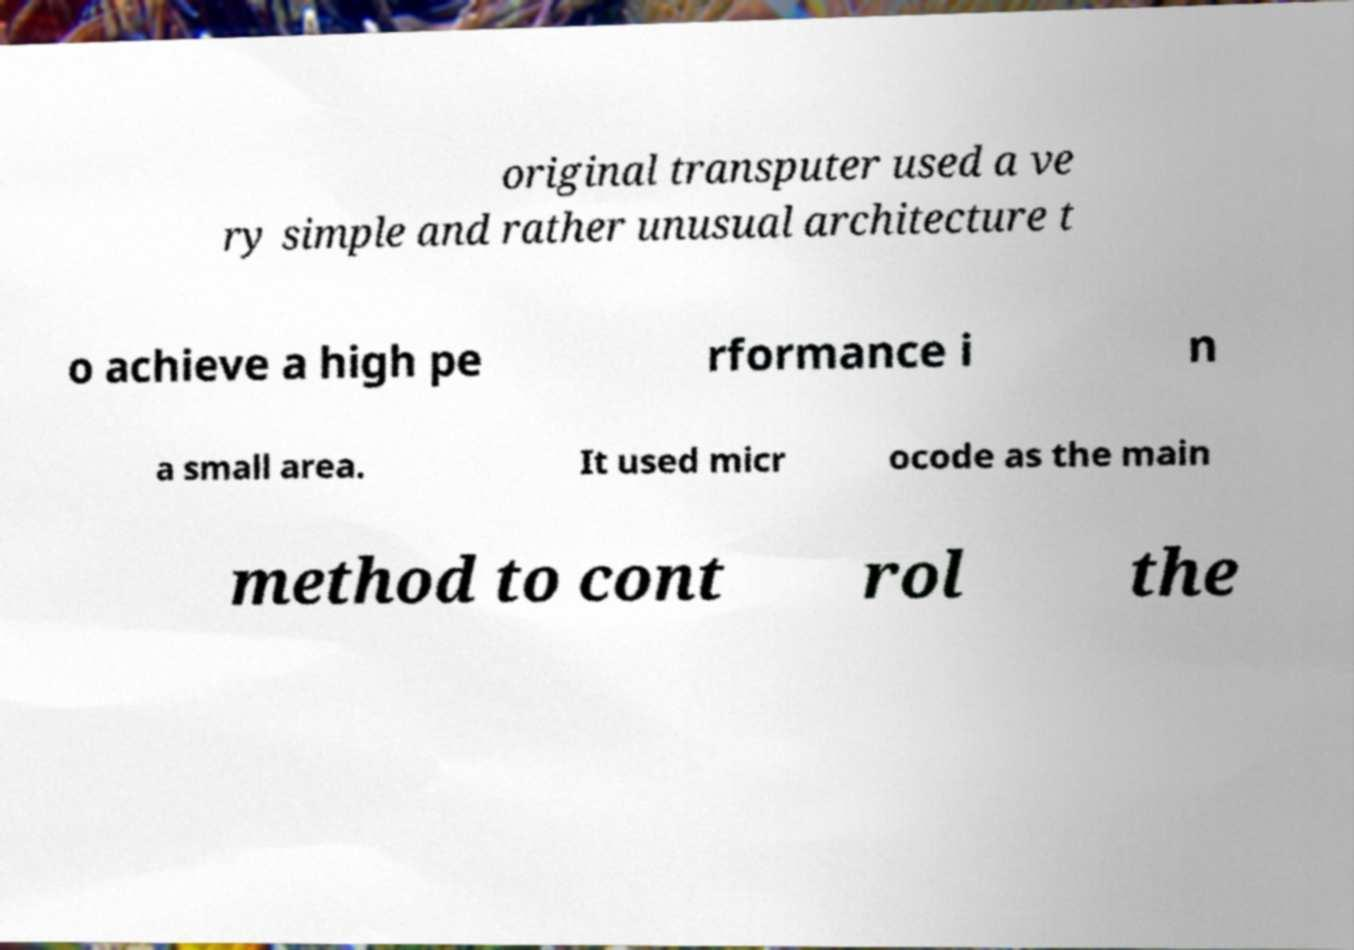Can you read and provide the text displayed in the image?This photo seems to have some interesting text. Can you extract and type it out for me? original transputer used a ve ry simple and rather unusual architecture t o achieve a high pe rformance i n a small area. It used micr ocode as the main method to cont rol the 